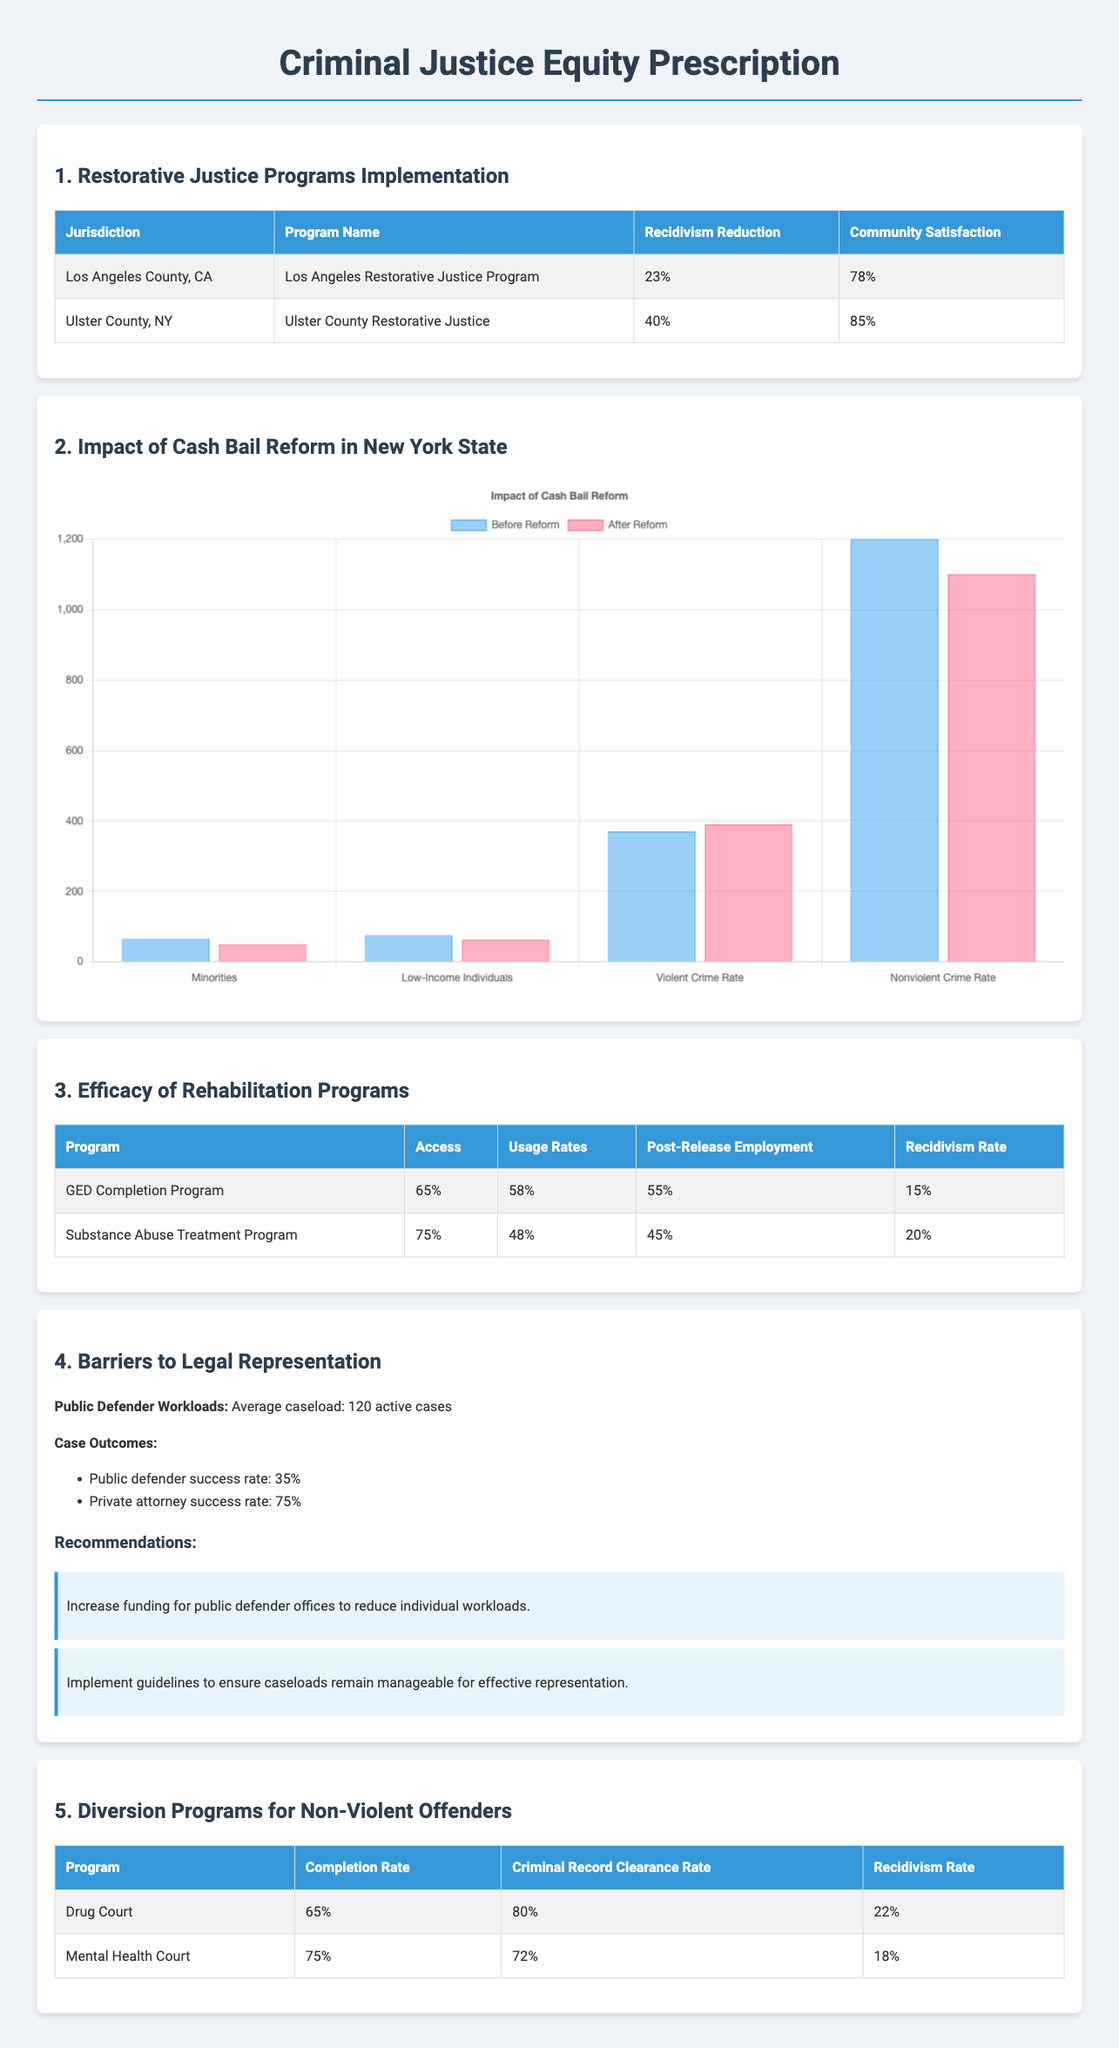What is the recidivism reduction for Ulster County? The recidivism reduction for Ulster County is stated in the table under Restorative Justice Programs Implementation.
Answer: 40% What is the community satisfaction percentage for Los Angeles County? The community satisfaction percentage can be found in the same table under Restorative Justice Programs Implementation.
Answer: 78% What is the average public defender caseload? The average public defender caseload is mentioned in the section on Barriers to Legal Representation.
Answer: 120 active cases What is the completion rate for the Mental Health Court program? The completion rate is listed in the Diversion Programs for Non-Violent Offenders table.
Answer: 75% What was the violent crime rate before cash bail reform? This information can be extracted from the bail reform chart under the Impact of Cash Bail Reform in New York State section.
Answer: 370 How much did the recidivism rate change for those in the Substance Abuse Treatment Program? This requires reasoning using the provided recidivism rate of 20% and the context from the document.
Answer: It did not change significantly, remaining at 20% What is the success rate for private attorneys compared to public defenders? This comparison is provided in the section on Barriers to Legal Representation regarding case outcomes.
Answer: 75% What is the community satisfaction percentage for Ulster County? The community satisfaction percentage can be found in the Restorative Justice Programs Implementation table.
Answer: 85% What are the data points compared before and after cash bail reform? The specific categories in the bail reform chart provide this data, showing demographic and crime metrics.
Answer: Minorities, Low-Income Individuals, Violent Crime Rate, Nonviolent Crime Rate 